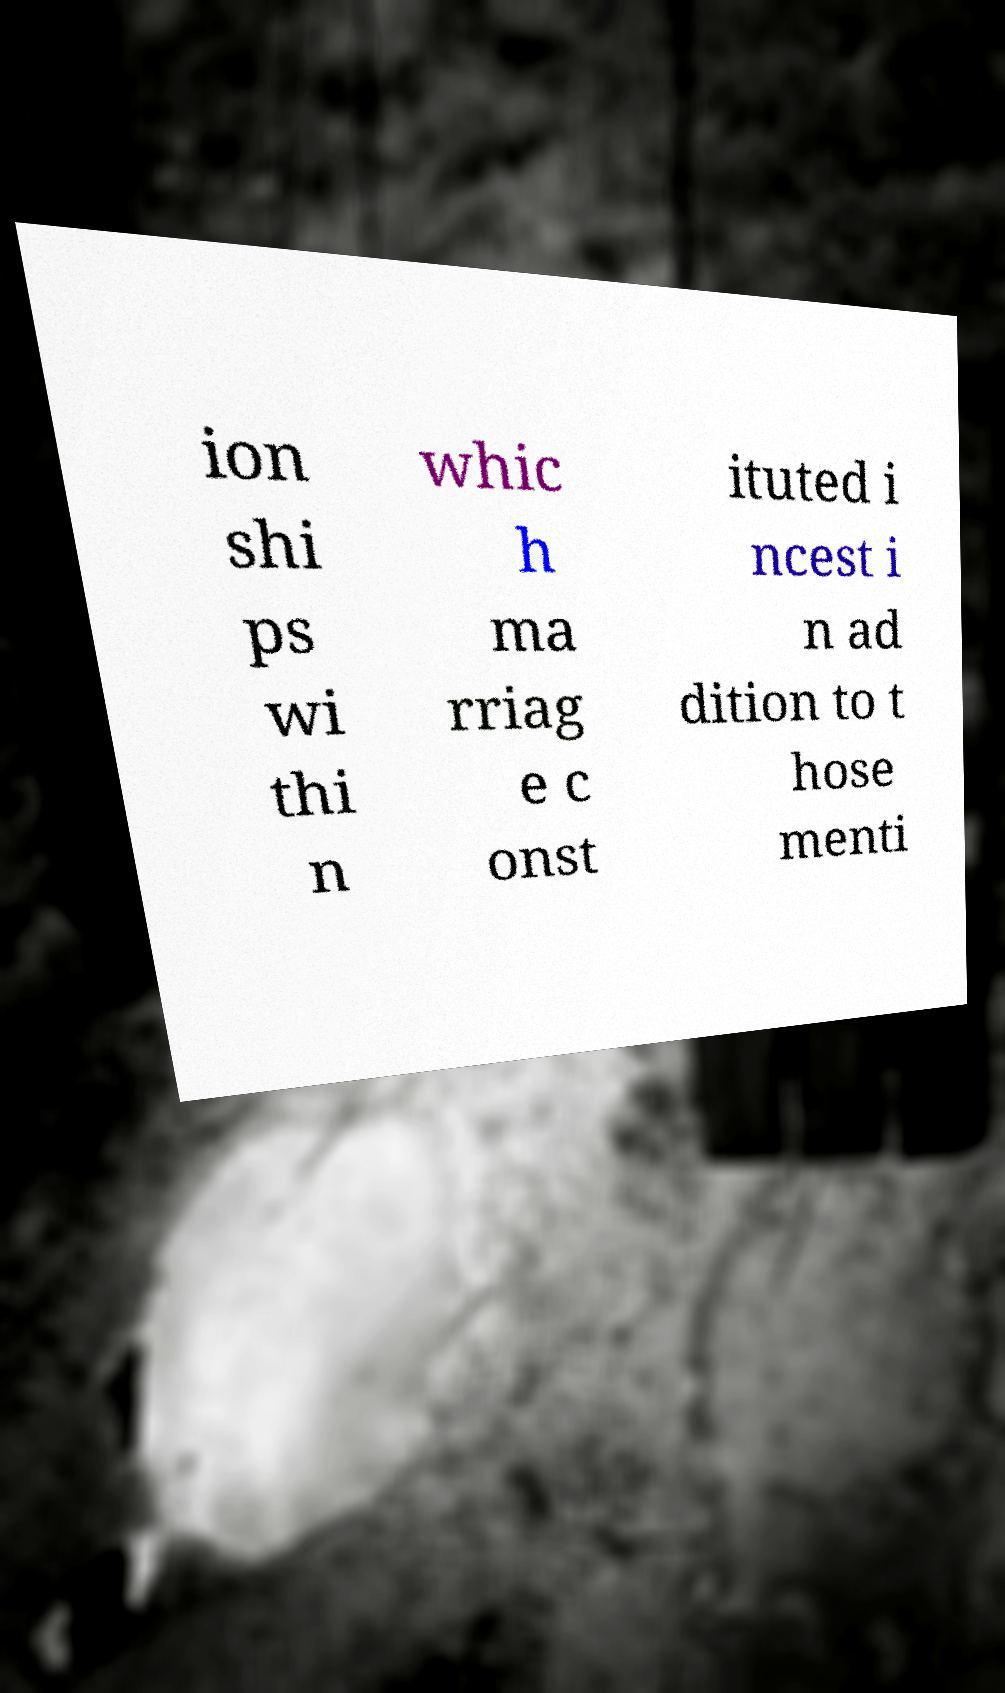There's text embedded in this image that I need extracted. Can you transcribe it verbatim? ion shi ps wi thi n whic h ma rriag e c onst ituted i ncest i n ad dition to t hose menti 